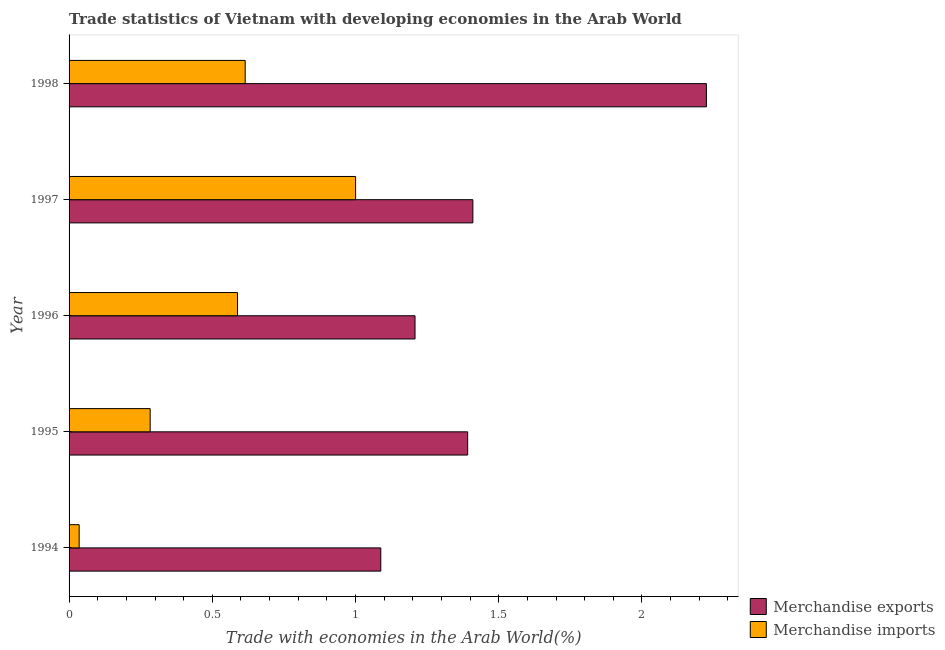Are the number of bars per tick equal to the number of legend labels?
Ensure brevity in your answer.  Yes. Are the number of bars on each tick of the Y-axis equal?
Keep it short and to the point. Yes. How many bars are there on the 2nd tick from the bottom?
Provide a succinct answer. 2. In how many cases, is the number of bars for a given year not equal to the number of legend labels?
Give a very brief answer. 0. What is the merchandise exports in 1998?
Provide a short and direct response. 2.23. Across all years, what is the maximum merchandise imports?
Provide a short and direct response. 1. Across all years, what is the minimum merchandise imports?
Your answer should be compact. 0.04. In which year was the merchandise exports maximum?
Keep it short and to the point. 1998. In which year was the merchandise imports minimum?
Keep it short and to the point. 1994. What is the total merchandise exports in the graph?
Provide a succinct answer. 7.32. What is the difference between the merchandise imports in 1997 and that in 1998?
Provide a succinct answer. 0.39. What is the difference between the merchandise imports in 1998 and the merchandise exports in 1996?
Offer a very short reply. -0.59. What is the average merchandise imports per year?
Provide a short and direct response. 0.5. In the year 1995, what is the difference between the merchandise exports and merchandise imports?
Offer a terse response. 1.11. What is the ratio of the merchandise imports in 1995 to that in 1998?
Your response must be concise. 0.46. Is the difference between the merchandise imports in 1994 and 1997 greater than the difference between the merchandise exports in 1994 and 1997?
Offer a very short reply. No. What is the difference between the highest and the second highest merchandise exports?
Ensure brevity in your answer.  0.81. In how many years, is the merchandise imports greater than the average merchandise imports taken over all years?
Keep it short and to the point. 3. Is the sum of the merchandise imports in 1995 and 1998 greater than the maximum merchandise exports across all years?
Your answer should be very brief. No. What does the 2nd bar from the bottom in 1997 represents?
Give a very brief answer. Merchandise imports. Are all the bars in the graph horizontal?
Your answer should be very brief. Yes. Does the graph contain grids?
Your response must be concise. No. What is the title of the graph?
Make the answer very short. Trade statistics of Vietnam with developing economies in the Arab World. What is the label or title of the X-axis?
Provide a succinct answer. Trade with economies in the Arab World(%). What is the label or title of the Y-axis?
Provide a short and direct response. Year. What is the Trade with economies in the Arab World(%) of Merchandise exports in 1994?
Your answer should be compact. 1.09. What is the Trade with economies in the Arab World(%) of Merchandise imports in 1994?
Your response must be concise. 0.04. What is the Trade with economies in the Arab World(%) in Merchandise exports in 1995?
Provide a succinct answer. 1.39. What is the Trade with economies in the Arab World(%) of Merchandise imports in 1995?
Offer a very short reply. 0.28. What is the Trade with economies in the Arab World(%) of Merchandise exports in 1996?
Offer a very short reply. 1.21. What is the Trade with economies in the Arab World(%) in Merchandise imports in 1996?
Offer a very short reply. 0.59. What is the Trade with economies in the Arab World(%) of Merchandise exports in 1997?
Provide a succinct answer. 1.41. What is the Trade with economies in the Arab World(%) of Merchandise imports in 1997?
Provide a short and direct response. 1. What is the Trade with economies in the Arab World(%) in Merchandise exports in 1998?
Ensure brevity in your answer.  2.23. What is the Trade with economies in the Arab World(%) in Merchandise imports in 1998?
Your response must be concise. 0.61. Across all years, what is the maximum Trade with economies in the Arab World(%) of Merchandise exports?
Ensure brevity in your answer.  2.23. Across all years, what is the maximum Trade with economies in the Arab World(%) in Merchandise imports?
Give a very brief answer. 1. Across all years, what is the minimum Trade with economies in the Arab World(%) of Merchandise exports?
Your response must be concise. 1.09. Across all years, what is the minimum Trade with economies in the Arab World(%) in Merchandise imports?
Provide a succinct answer. 0.04. What is the total Trade with economies in the Arab World(%) in Merchandise exports in the graph?
Offer a terse response. 7.32. What is the total Trade with economies in the Arab World(%) in Merchandise imports in the graph?
Your answer should be very brief. 2.52. What is the difference between the Trade with economies in the Arab World(%) of Merchandise exports in 1994 and that in 1995?
Your answer should be compact. -0.3. What is the difference between the Trade with economies in the Arab World(%) of Merchandise imports in 1994 and that in 1995?
Make the answer very short. -0.25. What is the difference between the Trade with economies in the Arab World(%) in Merchandise exports in 1994 and that in 1996?
Offer a terse response. -0.12. What is the difference between the Trade with economies in the Arab World(%) in Merchandise imports in 1994 and that in 1996?
Make the answer very short. -0.55. What is the difference between the Trade with economies in the Arab World(%) of Merchandise exports in 1994 and that in 1997?
Give a very brief answer. -0.32. What is the difference between the Trade with economies in the Arab World(%) of Merchandise imports in 1994 and that in 1997?
Provide a succinct answer. -0.97. What is the difference between the Trade with economies in the Arab World(%) in Merchandise exports in 1994 and that in 1998?
Offer a terse response. -1.14. What is the difference between the Trade with economies in the Arab World(%) in Merchandise imports in 1994 and that in 1998?
Your answer should be very brief. -0.58. What is the difference between the Trade with economies in the Arab World(%) in Merchandise exports in 1995 and that in 1996?
Your response must be concise. 0.18. What is the difference between the Trade with economies in the Arab World(%) of Merchandise imports in 1995 and that in 1996?
Your answer should be compact. -0.3. What is the difference between the Trade with economies in the Arab World(%) of Merchandise exports in 1995 and that in 1997?
Give a very brief answer. -0.02. What is the difference between the Trade with economies in the Arab World(%) of Merchandise imports in 1995 and that in 1997?
Offer a very short reply. -0.72. What is the difference between the Trade with economies in the Arab World(%) in Merchandise exports in 1995 and that in 1998?
Ensure brevity in your answer.  -0.83. What is the difference between the Trade with economies in the Arab World(%) in Merchandise imports in 1995 and that in 1998?
Your response must be concise. -0.33. What is the difference between the Trade with economies in the Arab World(%) in Merchandise exports in 1996 and that in 1997?
Offer a very short reply. -0.2. What is the difference between the Trade with economies in the Arab World(%) of Merchandise imports in 1996 and that in 1997?
Ensure brevity in your answer.  -0.41. What is the difference between the Trade with economies in the Arab World(%) of Merchandise exports in 1996 and that in 1998?
Provide a succinct answer. -1.02. What is the difference between the Trade with economies in the Arab World(%) in Merchandise imports in 1996 and that in 1998?
Give a very brief answer. -0.03. What is the difference between the Trade with economies in the Arab World(%) in Merchandise exports in 1997 and that in 1998?
Give a very brief answer. -0.82. What is the difference between the Trade with economies in the Arab World(%) of Merchandise imports in 1997 and that in 1998?
Your answer should be compact. 0.39. What is the difference between the Trade with economies in the Arab World(%) in Merchandise exports in 1994 and the Trade with economies in the Arab World(%) in Merchandise imports in 1995?
Offer a very short reply. 0.81. What is the difference between the Trade with economies in the Arab World(%) of Merchandise exports in 1994 and the Trade with economies in the Arab World(%) of Merchandise imports in 1996?
Ensure brevity in your answer.  0.5. What is the difference between the Trade with economies in the Arab World(%) of Merchandise exports in 1994 and the Trade with economies in the Arab World(%) of Merchandise imports in 1997?
Your answer should be compact. 0.09. What is the difference between the Trade with economies in the Arab World(%) in Merchandise exports in 1994 and the Trade with economies in the Arab World(%) in Merchandise imports in 1998?
Keep it short and to the point. 0.47. What is the difference between the Trade with economies in the Arab World(%) in Merchandise exports in 1995 and the Trade with economies in the Arab World(%) in Merchandise imports in 1996?
Offer a terse response. 0.8. What is the difference between the Trade with economies in the Arab World(%) in Merchandise exports in 1995 and the Trade with economies in the Arab World(%) in Merchandise imports in 1997?
Offer a very short reply. 0.39. What is the difference between the Trade with economies in the Arab World(%) in Merchandise exports in 1995 and the Trade with economies in the Arab World(%) in Merchandise imports in 1998?
Your answer should be compact. 0.78. What is the difference between the Trade with economies in the Arab World(%) of Merchandise exports in 1996 and the Trade with economies in the Arab World(%) of Merchandise imports in 1997?
Your answer should be very brief. 0.21. What is the difference between the Trade with economies in the Arab World(%) of Merchandise exports in 1996 and the Trade with economies in the Arab World(%) of Merchandise imports in 1998?
Your response must be concise. 0.59. What is the difference between the Trade with economies in the Arab World(%) of Merchandise exports in 1997 and the Trade with economies in the Arab World(%) of Merchandise imports in 1998?
Your answer should be very brief. 0.79. What is the average Trade with economies in the Arab World(%) of Merchandise exports per year?
Give a very brief answer. 1.46. What is the average Trade with economies in the Arab World(%) in Merchandise imports per year?
Provide a short and direct response. 0.5. In the year 1994, what is the difference between the Trade with economies in the Arab World(%) of Merchandise exports and Trade with economies in the Arab World(%) of Merchandise imports?
Your response must be concise. 1.05. In the year 1995, what is the difference between the Trade with economies in the Arab World(%) in Merchandise exports and Trade with economies in the Arab World(%) in Merchandise imports?
Keep it short and to the point. 1.11. In the year 1996, what is the difference between the Trade with economies in the Arab World(%) in Merchandise exports and Trade with economies in the Arab World(%) in Merchandise imports?
Provide a short and direct response. 0.62. In the year 1997, what is the difference between the Trade with economies in the Arab World(%) of Merchandise exports and Trade with economies in the Arab World(%) of Merchandise imports?
Make the answer very short. 0.41. In the year 1998, what is the difference between the Trade with economies in the Arab World(%) in Merchandise exports and Trade with economies in the Arab World(%) in Merchandise imports?
Provide a short and direct response. 1.61. What is the ratio of the Trade with economies in the Arab World(%) of Merchandise exports in 1994 to that in 1995?
Your answer should be compact. 0.78. What is the ratio of the Trade with economies in the Arab World(%) of Merchandise imports in 1994 to that in 1995?
Make the answer very short. 0.12. What is the ratio of the Trade with economies in the Arab World(%) in Merchandise exports in 1994 to that in 1996?
Offer a very short reply. 0.9. What is the ratio of the Trade with economies in the Arab World(%) of Merchandise imports in 1994 to that in 1996?
Provide a succinct answer. 0.06. What is the ratio of the Trade with economies in the Arab World(%) of Merchandise exports in 1994 to that in 1997?
Give a very brief answer. 0.77. What is the ratio of the Trade with economies in the Arab World(%) of Merchandise imports in 1994 to that in 1997?
Offer a terse response. 0.04. What is the ratio of the Trade with economies in the Arab World(%) of Merchandise exports in 1994 to that in 1998?
Ensure brevity in your answer.  0.49. What is the ratio of the Trade with economies in the Arab World(%) in Merchandise imports in 1994 to that in 1998?
Your answer should be very brief. 0.06. What is the ratio of the Trade with economies in the Arab World(%) in Merchandise exports in 1995 to that in 1996?
Provide a succinct answer. 1.15. What is the ratio of the Trade with economies in the Arab World(%) in Merchandise imports in 1995 to that in 1996?
Make the answer very short. 0.48. What is the ratio of the Trade with economies in the Arab World(%) of Merchandise exports in 1995 to that in 1997?
Provide a short and direct response. 0.99. What is the ratio of the Trade with economies in the Arab World(%) of Merchandise imports in 1995 to that in 1997?
Your answer should be very brief. 0.28. What is the ratio of the Trade with economies in the Arab World(%) of Merchandise exports in 1995 to that in 1998?
Your response must be concise. 0.63. What is the ratio of the Trade with economies in the Arab World(%) of Merchandise imports in 1995 to that in 1998?
Provide a succinct answer. 0.46. What is the ratio of the Trade with economies in the Arab World(%) of Merchandise exports in 1996 to that in 1997?
Give a very brief answer. 0.86. What is the ratio of the Trade with economies in the Arab World(%) in Merchandise imports in 1996 to that in 1997?
Your answer should be very brief. 0.59. What is the ratio of the Trade with economies in the Arab World(%) in Merchandise exports in 1996 to that in 1998?
Provide a short and direct response. 0.54. What is the ratio of the Trade with economies in the Arab World(%) in Merchandise imports in 1996 to that in 1998?
Provide a short and direct response. 0.96. What is the ratio of the Trade with economies in the Arab World(%) of Merchandise exports in 1997 to that in 1998?
Ensure brevity in your answer.  0.63. What is the ratio of the Trade with economies in the Arab World(%) of Merchandise imports in 1997 to that in 1998?
Provide a succinct answer. 1.63. What is the difference between the highest and the second highest Trade with economies in the Arab World(%) in Merchandise exports?
Offer a terse response. 0.82. What is the difference between the highest and the second highest Trade with economies in the Arab World(%) of Merchandise imports?
Keep it short and to the point. 0.39. What is the difference between the highest and the lowest Trade with economies in the Arab World(%) of Merchandise exports?
Keep it short and to the point. 1.14. What is the difference between the highest and the lowest Trade with economies in the Arab World(%) of Merchandise imports?
Make the answer very short. 0.97. 